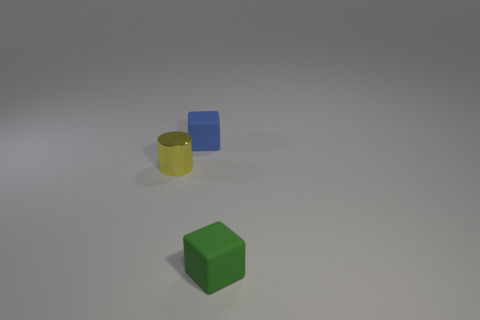What could be the purpose of this arrangement, considering artistic or demonstrative intentions? Artistically, the arrangement could be an exercise in minimalism, focusing on color contrasts, shapes, and composition balance. Demonstratively, it could be an illustration of spatial relationships and perspective, showing how different shapes relate to each other within a three-dimensional space. 